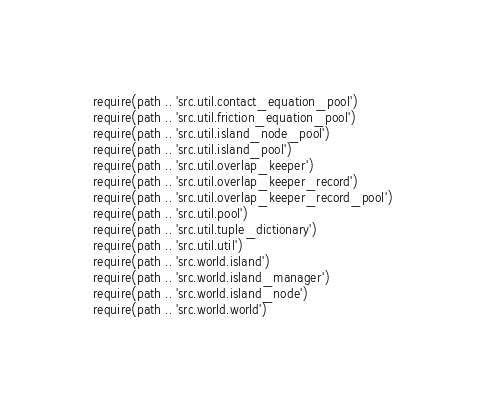Convert code to text. <code><loc_0><loc_0><loc_500><loc_500><_Lua_>require(path .. 'src.util.contact_equation_pool')
require(path .. 'src.util.friction_equation_pool')
require(path .. 'src.util.island_node_pool')
require(path .. 'src.util.island_pool')
require(path .. 'src.util.overlap_keeper')
require(path .. 'src.util.overlap_keeper_record')
require(path .. 'src.util.overlap_keeper_record_pool')
require(path .. 'src.util.pool')
require(path .. 'src.util.tuple_dictionary')
require(path .. 'src.util.util')
require(path .. 'src.world.island')
require(path .. 'src.world.island_manager')
require(path .. 'src.world.island_node')
require(path .. 'src.world.world')
</code> 